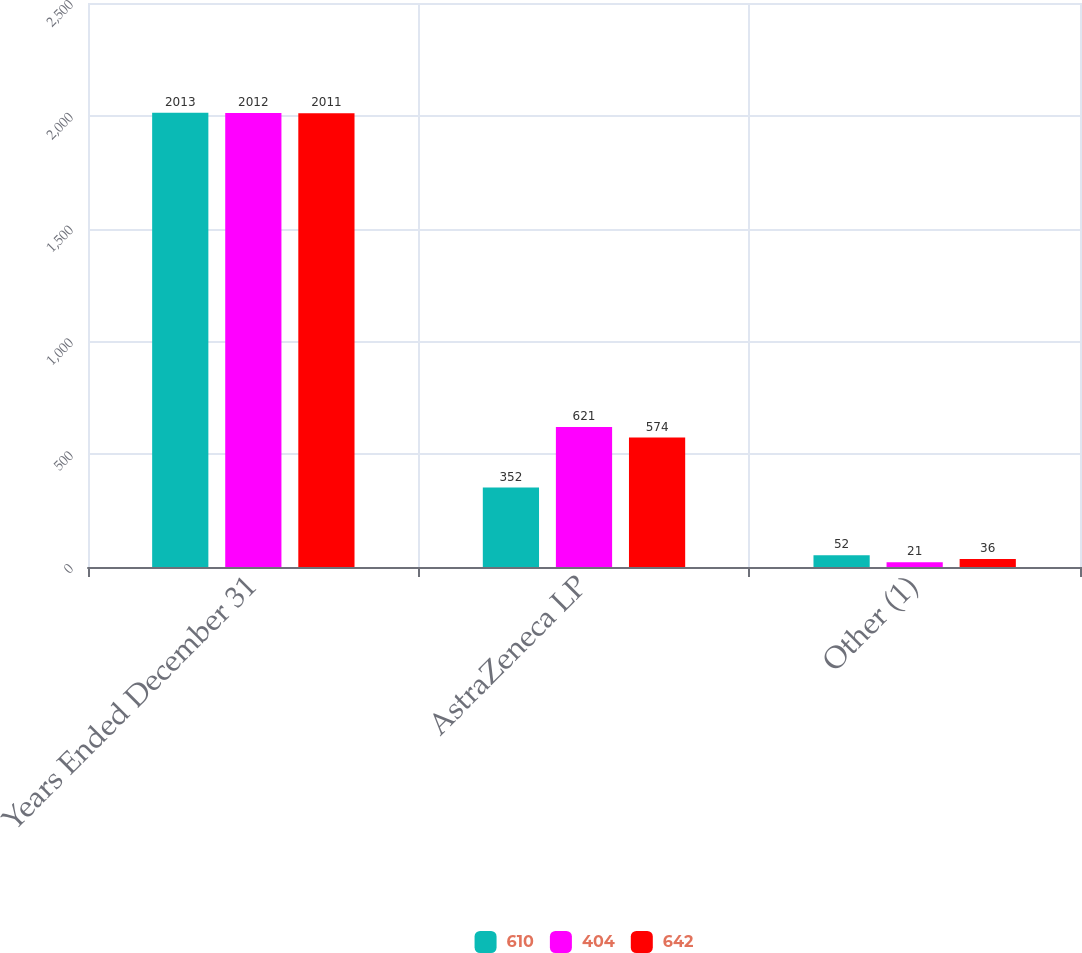Convert chart to OTSL. <chart><loc_0><loc_0><loc_500><loc_500><stacked_bar_chart><ecel><fcel>Years Ended December 31<fcel>AstraZeneca LP<fcel>Other (1)<nl><fcel>610<fcel>2013<fcel>352<fcel>52<nl><fcel>404<fcel>2012<fcel>621<fcel>21<nl><fcel>642<fcel>2011<fcel>574<fcel>36<nl></chart> 